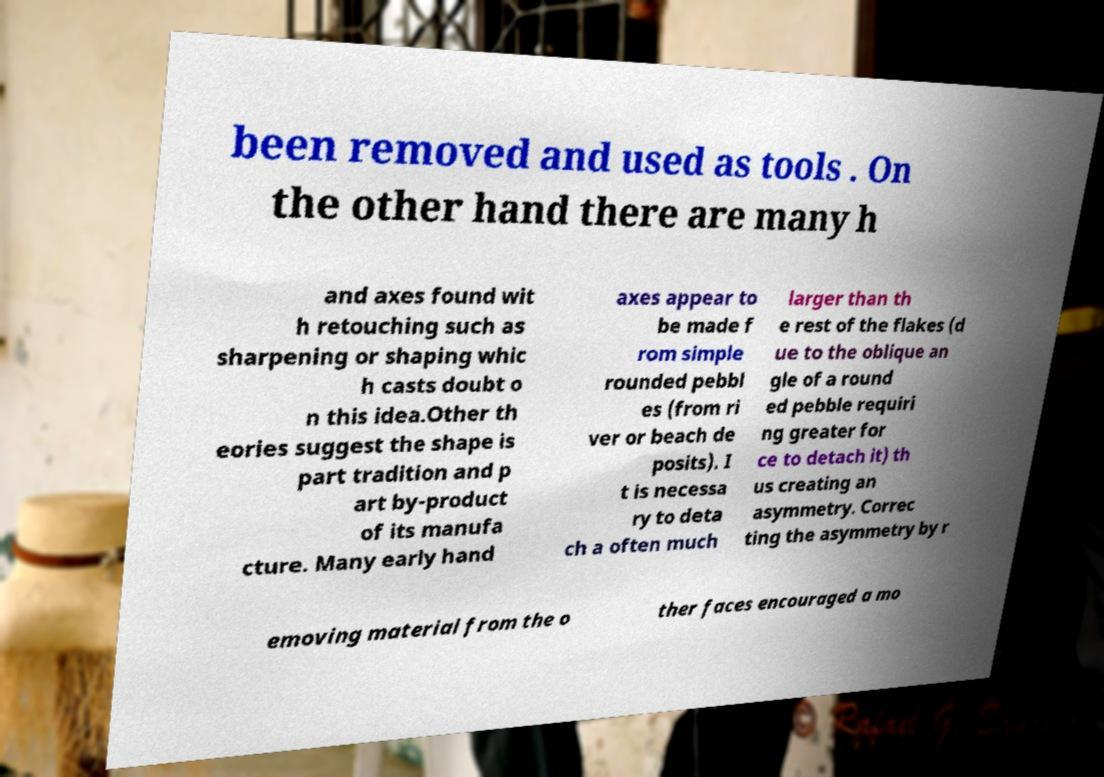Could you extract and type out the text from this image? been removed and used as tools . On the other hand there are many h and axes found wit h retouching such as sharpening or shaping whic h casts doubt o n this idea.Other th eories suggest the shape is part tradition and p art by-product of its manufa cture. Many early hand axes appear to be made f rom simple rounded pebbl es (from ri ver or beach de posits). I t is necessa ry to deta ch a often much larger than th e rest of the flakes (d ue to the oblique an gle of a round ed pebble requiri ng greater for ce to detach it) th us creating an asymmetry. Correc ting the asymmetry by r emoving material from the o ther faces encouraged a mo 